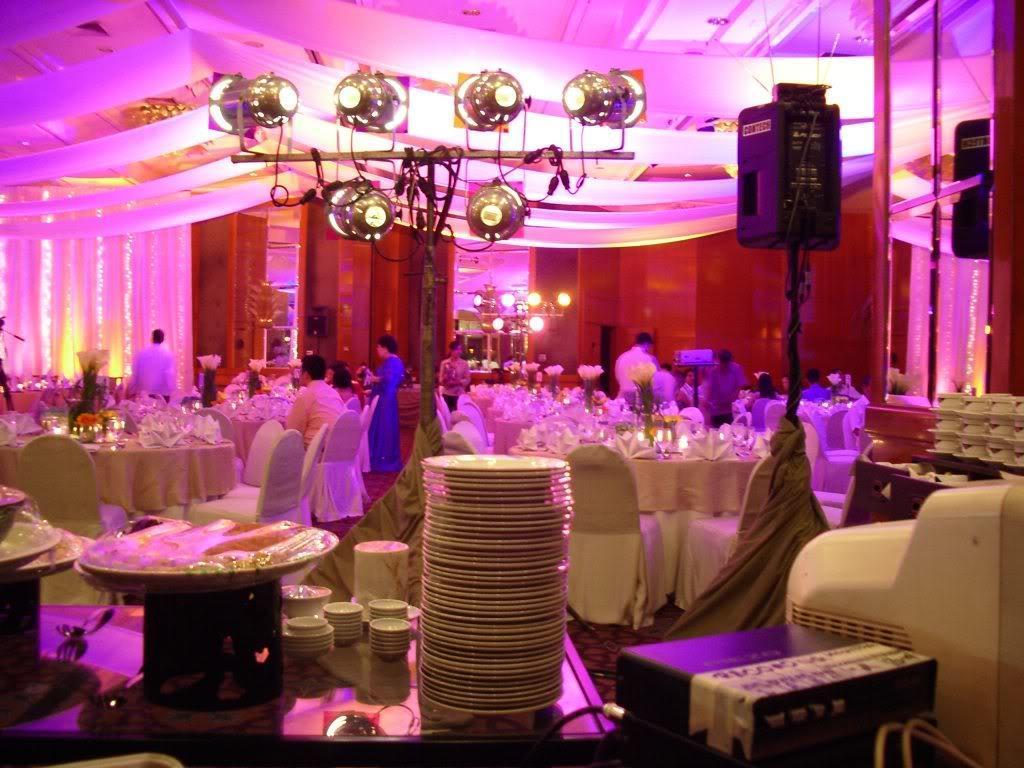Could you give a brief overview of what you see in this image? In this image, we can see chairs, tables. Few things and objects are placed on it. In the middle of the image, we can see a group of people. Few people are sitting and standing. Here we can see stands, lights, black box. Background there is a wall. Top of the image, we can see the ceiling and clothes. 